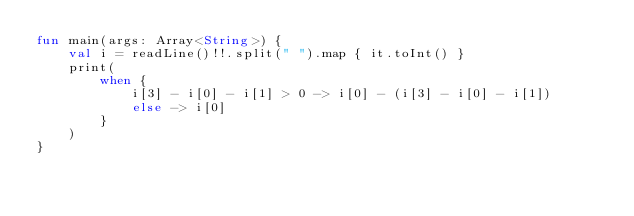Convert code to text. <code><loc_0><loc_0><loc_500><loc_500><_Kotlin_>fun main(args: Array<String>) {
    val i = readLine()!!.split(" ").map { it.toInt() }
    print(
        when {
            i[3] - i[0] - i[1] > 0 -> i[0] - (i[3] - i[0] - i[1])
            else -> i[0]
        }
    )
}</code> 